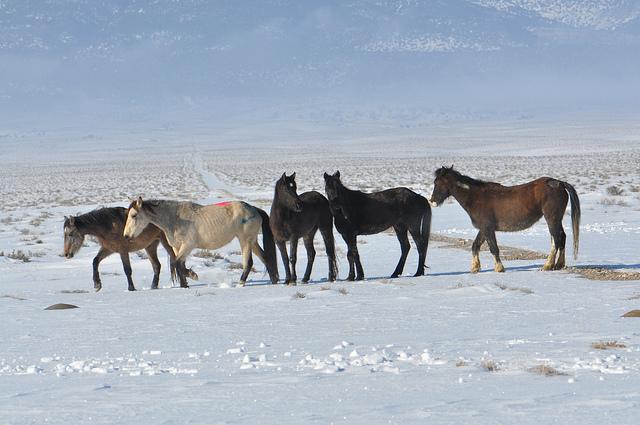Is there a road here?
Short answer required. No. How many horses are in the picture?
Keep it brief. 5. Would this make a good calendar shot?
Answer briefly. Yes. 